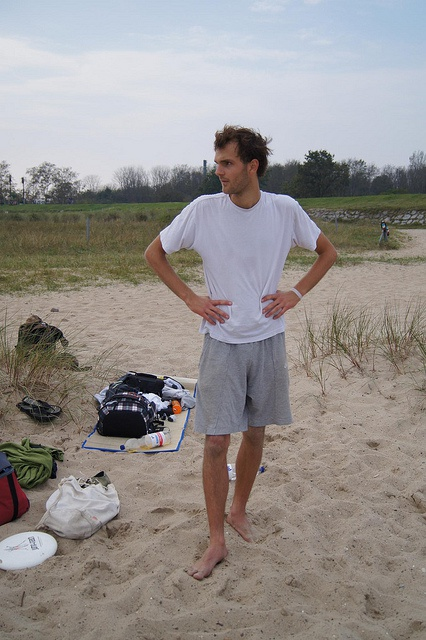Describe the objects in this image and their specific colors. I can see people in lightblue, darkgray, gray, and brown tones, backpack in lightblue, darkgray, gray, and lightgray tones, handbag in lightblue, darkgray, gray, and lightgray tones, backpack in lightblue, black, gray, and darkgray tones, and people in lightblue, black, darkgreen, and gray tones in this image. 